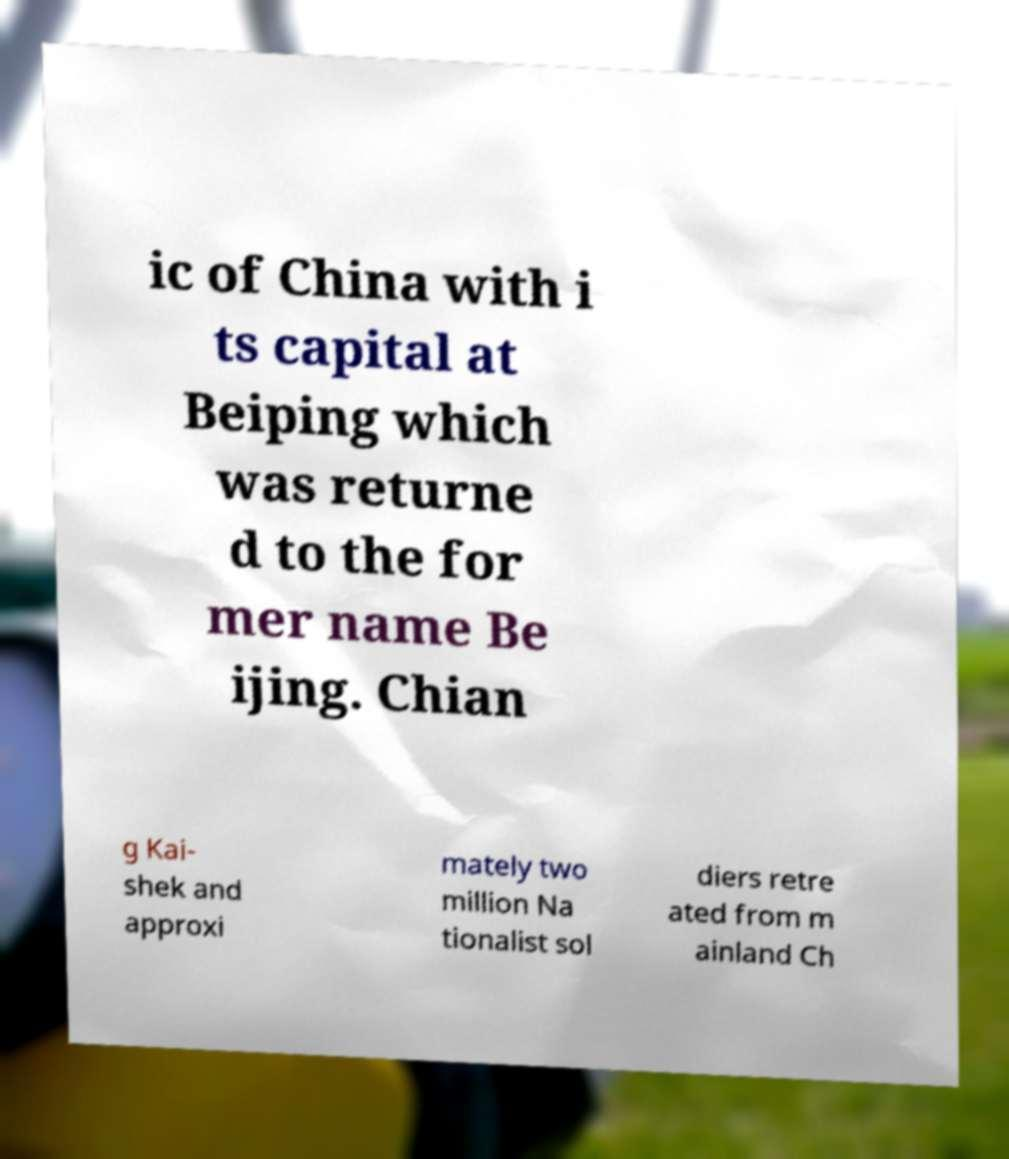I need the written content from this picture converted into text. Can you do that? ic of China with i ts capital at Beiping which was returne d to the for mer name Be ijing. Chian g Kai- shek and approxi mately two million Na tionalist sol diers retre ated from m ainland Ch 